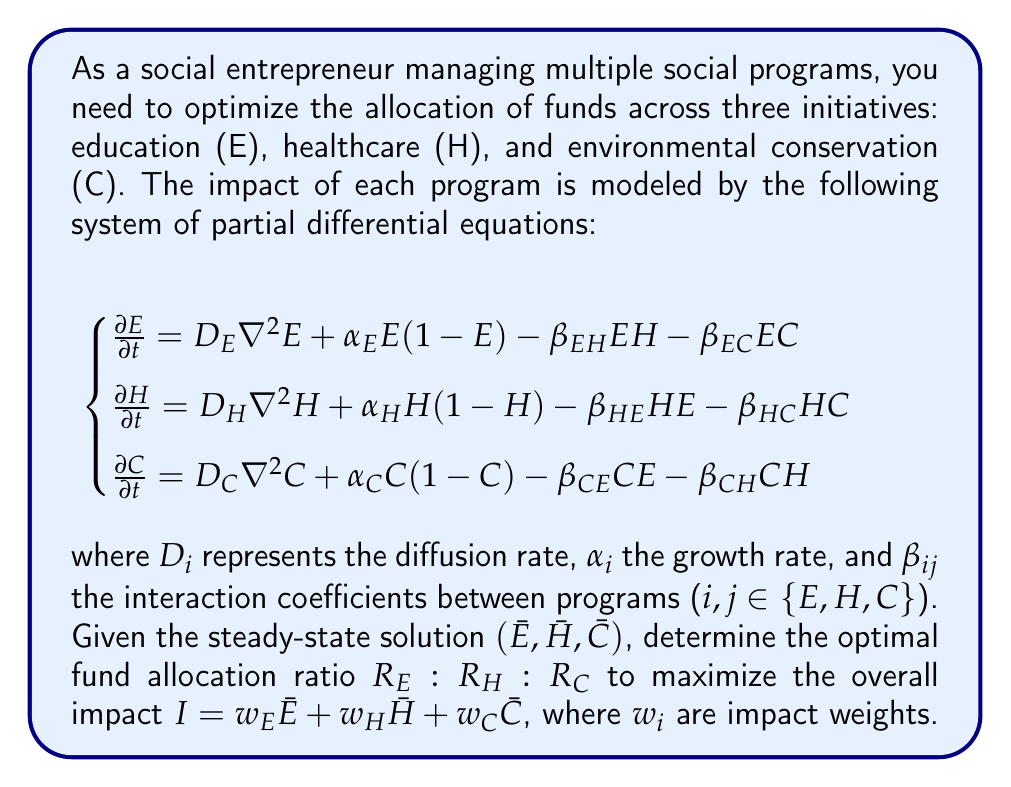Could you help me with this problem? To solve this problem, we'll follow these steps:

1) First, we need to find the steady-state solution. At steady-state, the time derivatives are zero:

   $$\begin{cases}
   0 = D_E \nabla^2 \bar{E} + \alpha_E \bar{E}(1-\bar{E}) - \beta_{EH}\bar{E}\bar{H} - \beta_{EC}\bar{E}\bar{C} \\
   0 = D_H \nabla^2 \bar{H} + \alpha_H \bar{H}(1-\bar{H}) - \beta_{HE}\bar{H}\bar{E} - \beta_{HC}\bar{H}\bar{C} \\
   0 = D_C \nabla^2 \bar{C} + \alpha_C \bar{C}(1-\bar{C}) - \beta_{CE}\bar{C}\bar{E} - \beta_{CH}\bar{C}\bar{H}
   \end{cases}$$

2) Assuming spatial homogeneity (i.e., $\nabla^2 \bar{E} = \nabla^2 \bar{H} = \nabla^2 \bar{C} = 0$), we get:

   $$\begin{cases}
   0 = \alpha_E \bar{E}(1-\bar{E}) - \beta_{EH}\bar{E}\bar{H} - \beta_{EC}\bar{E}\bar{C} \\
   0 = \alpha_H \bar{H}(1-\bar{H}) - \beta_{HE}\bar{H}\bar{E} - \beta_{HC}\bar{H}\bar{C} \\
   0 = \alpha_C \bar{C}(1-\bar{C}) - \beta_{CE}\bar{C}\bar{E} - \beta_{CH}\bar{C}\bar{H}
   \end{cases}$$

3) The steady-state values $(\bar{E}, \bar{H}, \bar{C})$ can be found by solving this system of equations numerically.

4) The impact function is $I = w_E\bar{E} + w_H\bar{H} + w_C\bar{C}$.

5) We assume that the steady-state values are functions of the fund allocation ratios: $\bar{E}(R_E), \bar{H}(R_H), \bar{C}(R_C)$.

6) To find the optimal allocation, we need to maximize $I$ subject to the constraint $R_E + R_H + R_C = 1$.

7) This can be done using the method of Lagrange multipliers. We form the Lagrangian:

   $$L = w_E\bar{E}(R_E) + w_H\bar{H}(R_H) + w_C\bar{C}(R_C) - \lambda(R_E + R_H + R_C - 1)$$

8) The optimal allocation satisfies:

   $$\begin{cases}
   w_E\frac{d\bar{E}}{dR_E} = \lambda \\
   w_H\frac{d\bar{H}}{dR_H} = \lambda \\
   w_C\frac{d\bar{C}}{dR_C} = \lambda \\
   R_E + R_H + R_C = 1
   \end{cases}$$

9) The derivatives $\frac{d\bar{E}}{dR_E}, \frac{d\bar{H}}{dR_H}, \frac{d\bar{C}}{dR_C}$ can be estimated numerically by slightly perturbing the allocation ratios and recalculating the steady-state values.

10) Solving this system of equations will give the optimal allocation ratios $R_E : R_H : R_C$.
Answer: The optimal fund allocation ratio $R_E : R_H : R_C$ is given by:

$$R_E : R_H : R_C = w_E\frac{d\bar{E}}{dR_E} : w_H\frac{d\bar{H}}{dR_H} : w_C\frac{d\bar{C}}{dR_C}$$

subject to $R_E + R_H + R_C = 1$, where $\frac{d\bar{E}}{dR_E}, \frac{d\bar{H}}{dR_H}, \frac{d\bar{C}}{dR_C}$ are determined numerically from the steady-state solutions of the PDE system. 